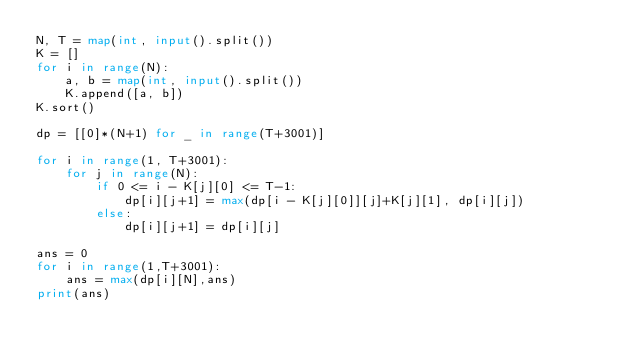<code> <loc_0><loc_0><loc_500><loc_500><_Python_>N, T = map(int, input().split())
K = []
for i in range(N):
    a, b = map(int, input().split())
    K.append([a, b])
K.sort()

dp = [[0]*(N+1) for _ in range(T+3001)]

for i in range(1, T+3001):
    for j in range(N):
        if 0 <= i - K[j][0] <= T-1:
            dp[i][j+1] = max(dp[i - K[j][0]][j]+K[j][1], dp[i][j])
        else:
            dp[i][j+1] = dp[i][j]

ans = 0
for i in range(1,T+3001):
    ans = max(dp[i][N],ans)
print(ans)</code> 